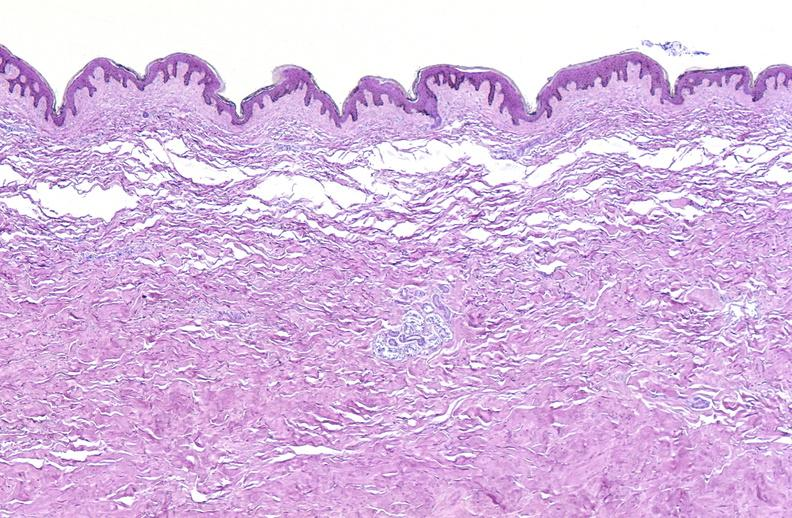does leukemic infiltrate with necrosis show scleroderma?
Answer the question using a single word or phrase. No 